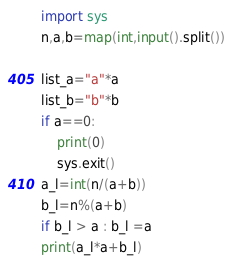<code> <loc_0><loc_0><loc_500><loc_500><_Python_>import sys
n,a,b=map(int,input().split())

list_a="a"*a
list_b="b"*b
if a==0:
    print(0)
    sys.exit()
a_l=int(n/(a+b))
b_l=n%(a+b)
if b_l > a : b_l =a
print(a_l*a+b_l)</code> 